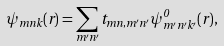<formula> <loc_0><loc_0><loc_500><loc_500>\psi _ { m n k } ( { r } ) = \sum _ { m ^ { \prime } n ^ { \prime } } t _ { m n , m ^ { \prime } n ^ { \prime } } \psi ^ { 0 } _ { m ^ { \prime } n ^ { \prime } k ^ { \prime } } ( { r } ) ,</formula> 